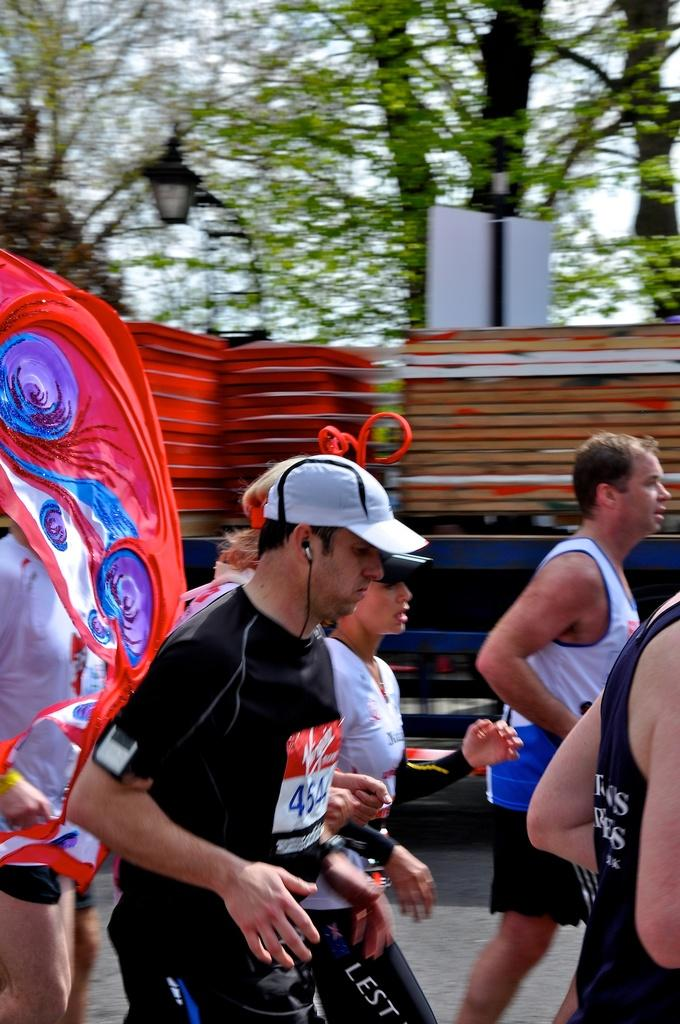Who or what can be seen in the image? There are people in the image. What is located in the background of the image? There is a board, a light, a vehicle, and trees in the background of the image. Can you see any visible veins on the people in the image? There is no information about the visibility of veins on the people in the image. --- 